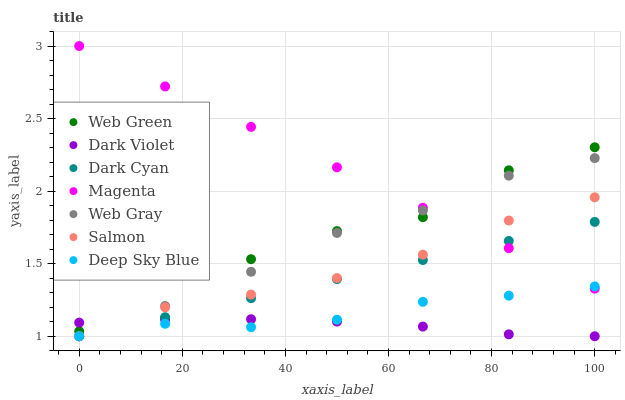Does Dark Violet have the minimum area under the curve?
Answer yes or no. Yes. Does Magenta have the maximum area under the curve?
Answer yes or no. Yes. Does Salmon have the minimum area under the curve?
Answer yes or no. No. Does Salmon have the maximum area under the curve?
Answer yes or no. No. Is Dark Cyan the smoothest?
Answer yes or no. Yes. Is Web Green the roughest?
Answer yes or no. Yes. Is Salmon the smoothest?
Answer yes or no. No. Is Salmon the roughest?
Answer yes or no. No. Does Web Gray have the lowest value?
Answer yes or no. Yes. Does Web Green have the lowest value?
Answer yes or no. No. Does Magenta have the highest value?
Answer yes or no. Yes. Does Salmon have the highest value?
Answer yes or no. No. Is Deep Sky Blue less than Web Green?
Answer yes or no. Yes. Is Magenta greater than Dark Violet?
Answer yes or no. Yes. Does Dark Cyan intersect Dark Violet?
Answer yes or no. Yes. Is Dark Cyan less than Dark Violet?
Answer yes or no. No. Is Dark Cyan greater than Dark Violet?
Answer yes or no. No. Does Deep Sky Blue intersect Web Green?
Answer yes or no. No. 